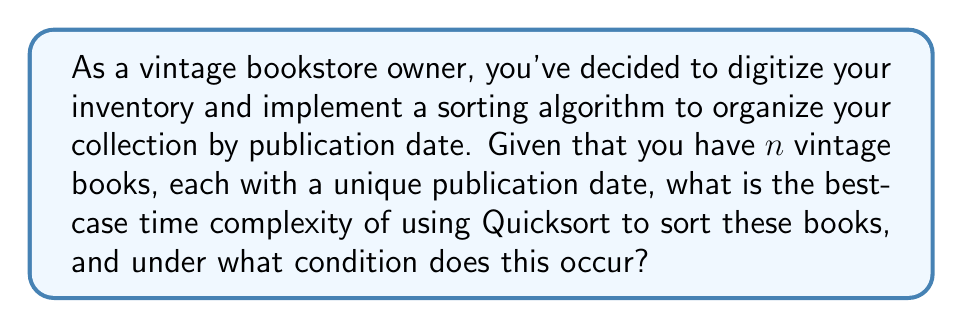Teach me how to tackle this problem. To analyze the best-case time complexity of Quicksort for sorting vintage books by publication date, we need to consider the following steps:

1. Quicksort algorithm:
   Quicksort is a divide-and-conquer algorithm that works by selecting a 'pivot' element and partitioning the array around the pivot.

2. Best-case scenario:
   The best-case for Quicksort occurs when the pivot chosen at each step divides the array into two nearly equal halves. This happens when the median element is consistently chosen as the pivot.

3. Recurrence relation:
   In the best-case scenario, the recurrence relation for Quicksort is:
   $$T(n) = 2T(n/2) + \Theta(n)$$
   Where $T(n)$ is the time complexity for sorting $n$ books, and $\Theta(n)$ represents the partitioning step.

4. Solving the recurrence:
   We can solve this recurrence using the Master Theorem. The recurrence fits the form:
   $$T(n) = aT(n/b) + f(n)$$
   Where $a=2$, $b=2$, and $f(n) = \Theta(n)$

5. Applying Master Theorem:
   We compare $n^{\log_b a} = n^{\log_2 2} = n$ with $f(n) = \Theta(n)$
   Since $f(n) = \Theta(n^{\log_b a})$, we fall into Case 2 of the Master Theorem.

6. Result:
   The solution for Case 2 of the Master Theorem is:
   $$T(n) = \Theta(n \log n)$$

This best-case scenario occurs when the pivot selection consistently divides the collection into two nearly equal parts, which is most likely when the books are in a random order with respect to their publication dates.
Answer: The best-case time complexity of Quicksort for sorting $n$ vintage books by publication date is $\Theta(n \log n)$. This occurs when the pivot selection consistently divides the collection into two nearly equal parts at each step of the algorithm. 